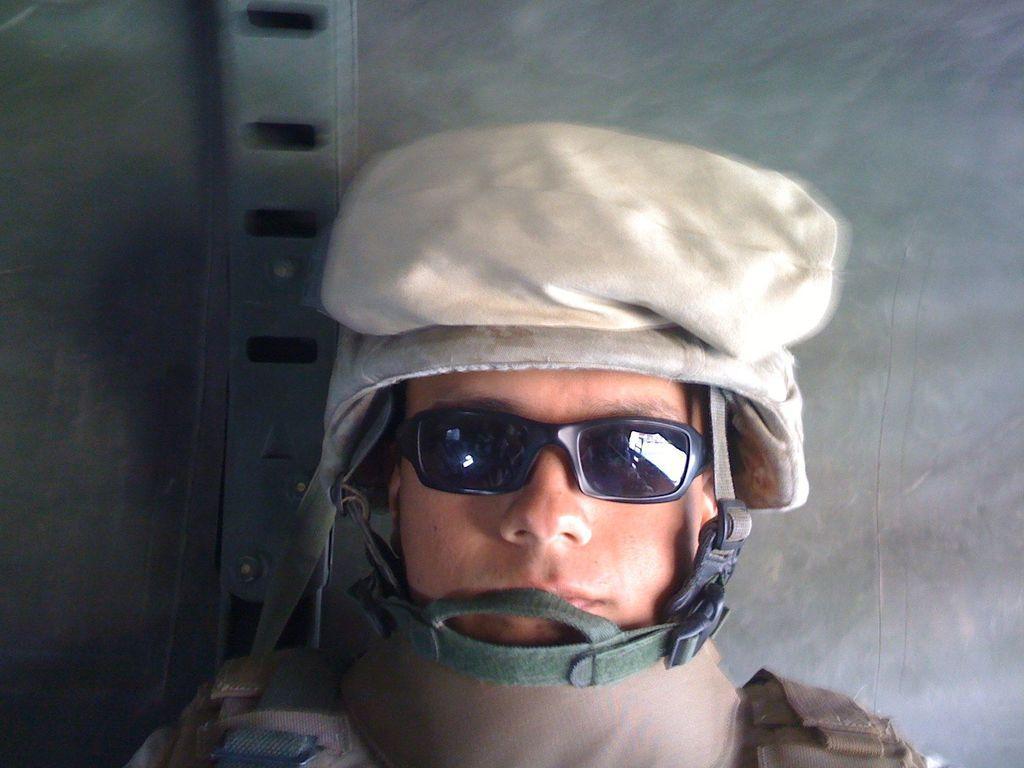In one or two sentences, can you explain what this image depicts? In this image I can see a person is wearing dress,cap and glasses. Background is in grey color. 